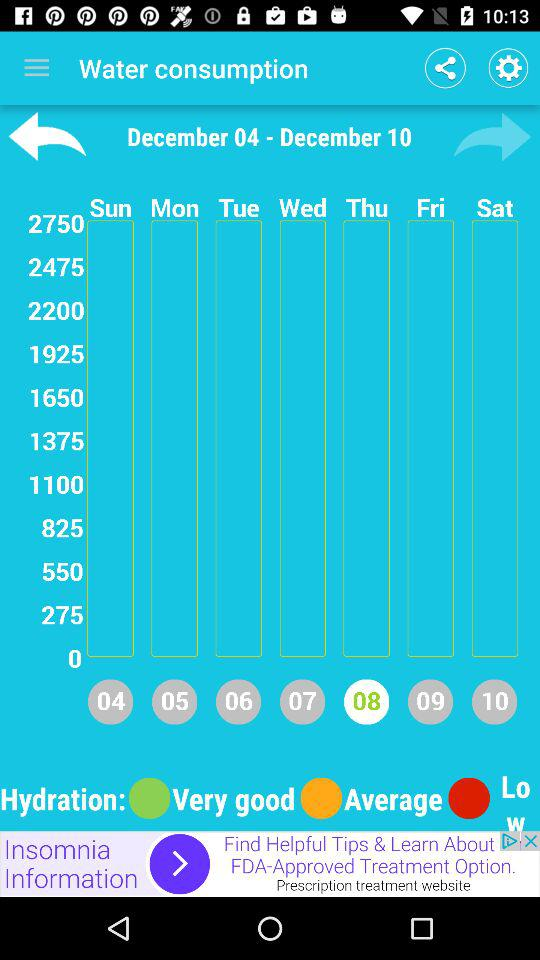Which date is highlighted? The highlighted date is Thursday, 8th December. 